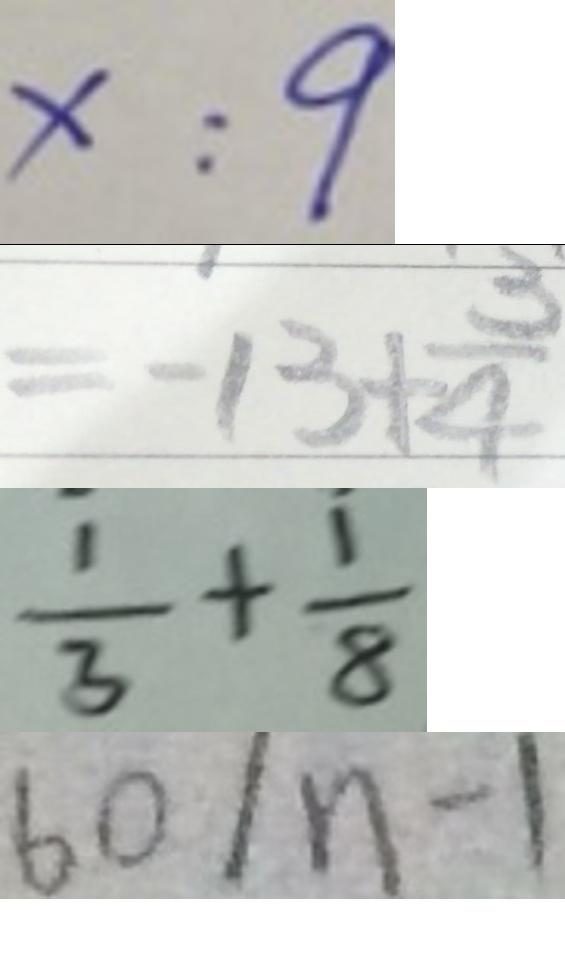<formula> <loc_0><loc_0><loc_500><loc_500>x : 9 
 = - 1 3 + \frac { 3 } { 4 } 
 = \frac { 1 } { 3 } + \frac { 1 } { 8 } 
 6 0 / n - 1</formula> 